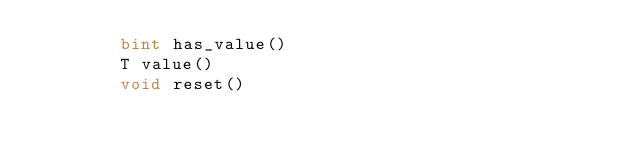Convert code to text. <code><loc_0><loc_0><loc_500><loc_500><_Cython_>        bint has_value()
        T value()
        void reset()
</code> 